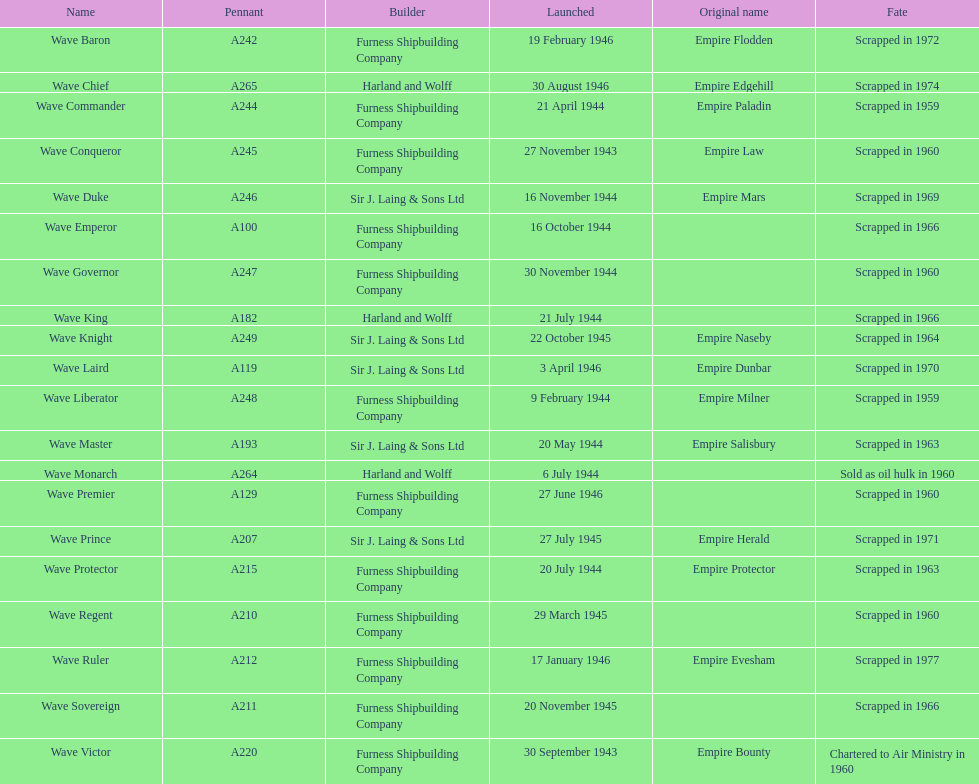In what year did the wave victor make its debut? 30 September 1943. What other maritime vessel was launched in 1943? Wave Conqueror. 